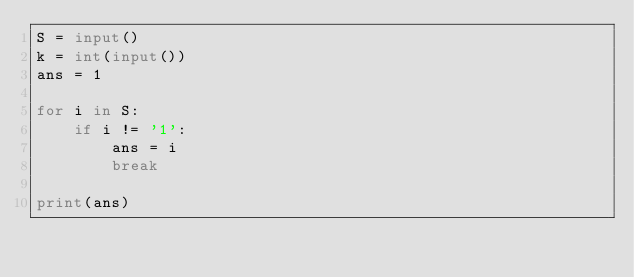<code> <loc_0><loc_0><loc_500><loc_500><_Python_>S = input()
k = int(input())
ans = 1

for i in S:
    if i != '1':
        ans = i
        break
        
print(ans)</code> 